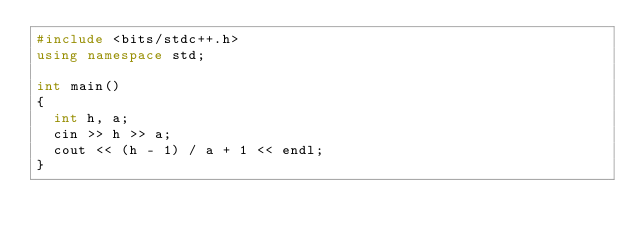Convert code to text. <code><loc_0><loc_0><loc_500><loc_500><_C++_>#include <bits/stdc++.h>
using namespace std;

int main()
{
  int h, a;
  cin >> h >> a;
  cout << (h - 1) / a + 1 << endl;
}</code> 